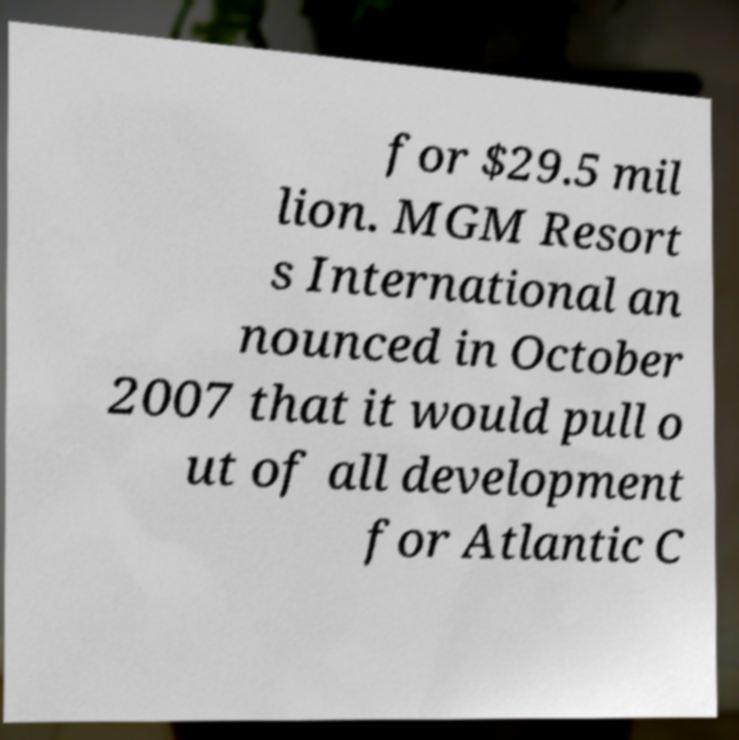Can you accurately transcribe the text from the provided image for me? for $29.5 mil lion. MGM Resort s International an nounced in October 2007 that it would pull o ut of all development for Atlantic C 